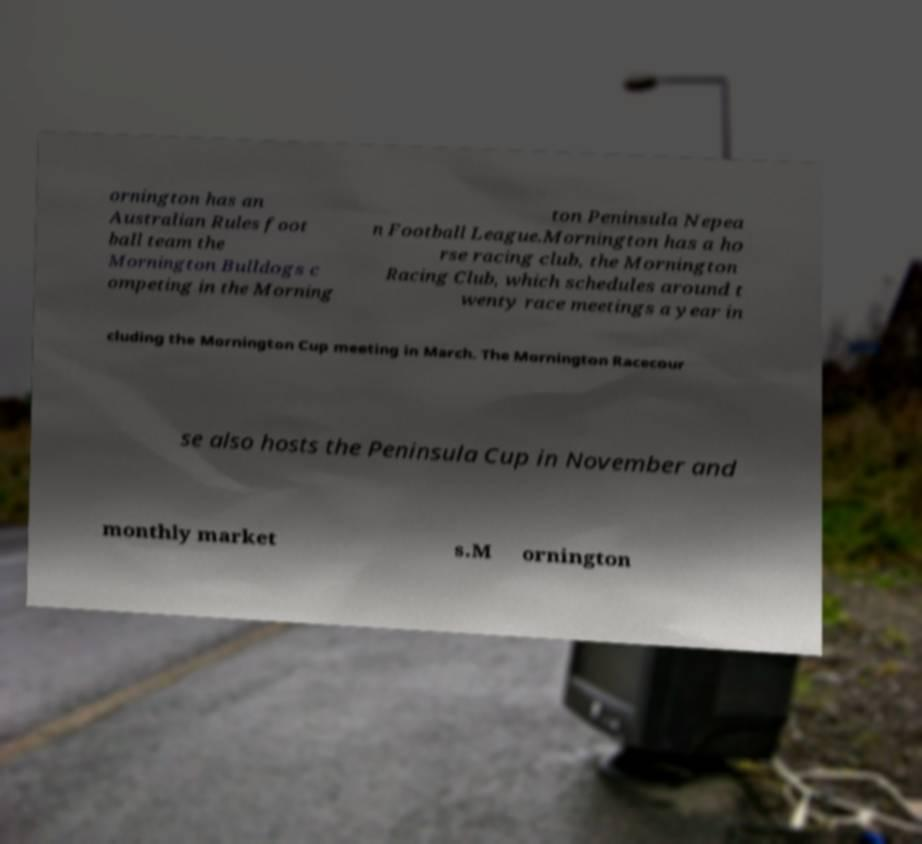For documentation purposes, I need the text within this image transcribed. Could you provide that? ornington has an Australian Rules foot ball team the Mornington Bulldogs c ompeting in the Morning ton Peninsula Nepea n Football League.Mornington has a ho rse racing club, the Mornington Racing Club, which schedules around t wenty race meetings a year in cluding the Mornington Cup meeting in March. The Mornington Racecour se also hosts the Peninsula Cup in November and monthly market s.M ornington 